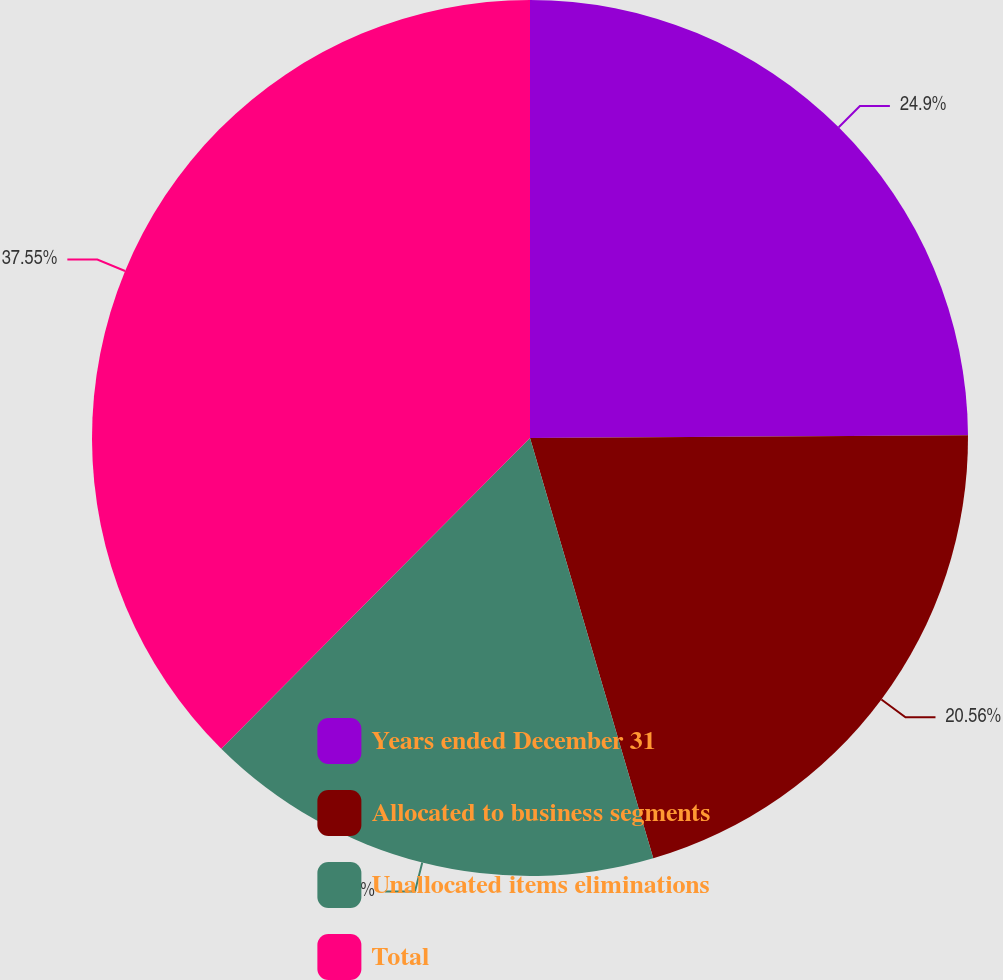<chart> <loc_0><loc_0><loc_500><loc_500><pie_chart><fcel>Years ended December 31<fcel>Allocated to business segments<fcel>Unallocated items eliminations<fcel>Total<nl><fcel>24.9%<fcel>20.56%<fcel>16.99%<fcel>37.55%<nl></chart> 